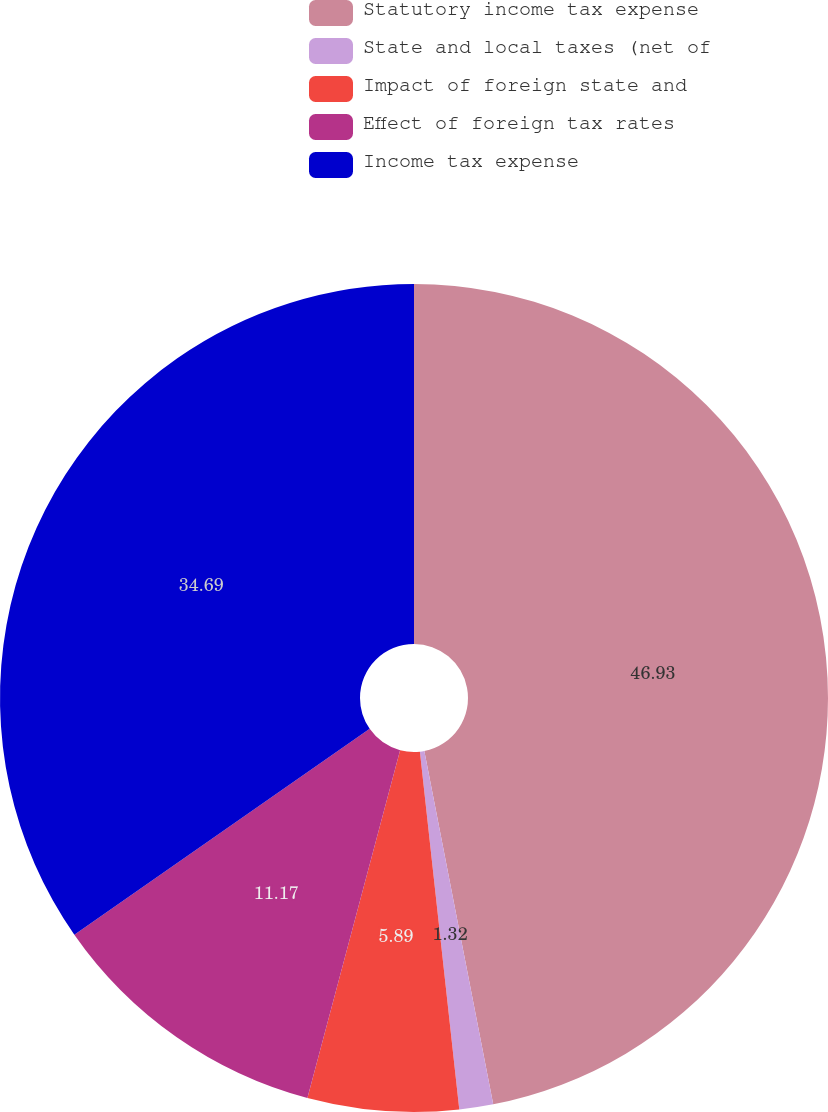Convert chart. <chart><loc_0><loc_0><loc_500><loc_500><pie_chart><fcel>Statutory income tax expense<fcel>State and local taxes (net of<fcel>Impact of foreign state and<fcel>Effect of foreign tax rates<fcel>Income tax expense<nl><fcel>46.94%<fcel>1.32%<fcel>5.89%<fcel>11.17%<fcel>34.69%<nl></chart> 